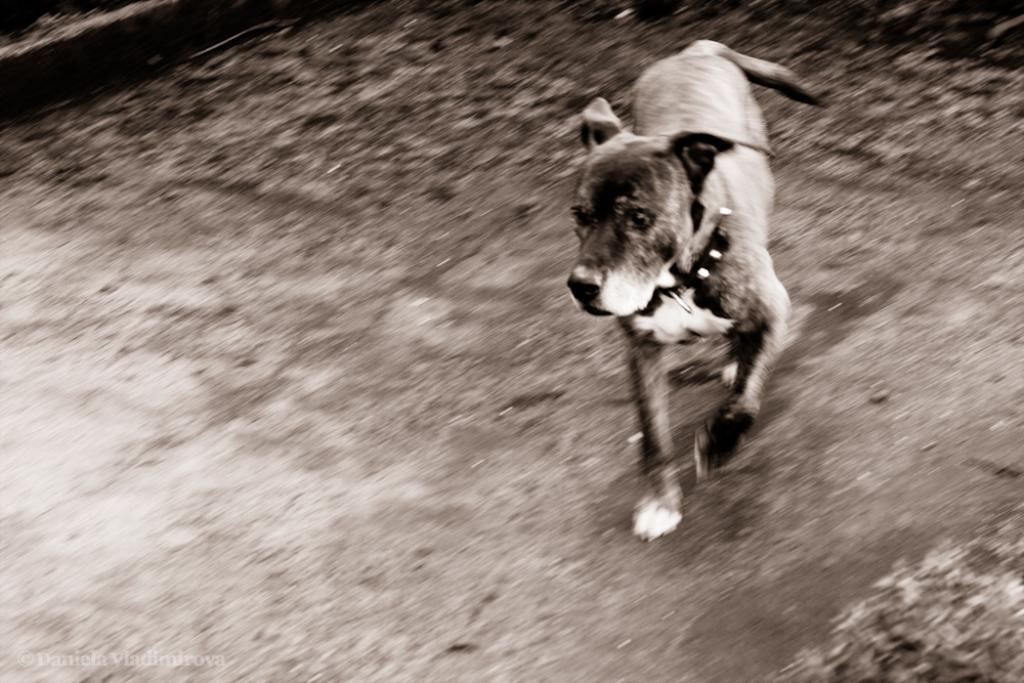What animal can be seen in the image? There is a dog in the image. What is the dog doing in the image? The dog is running on the ground. Can you describe the background of the image? The background of the image is blurry. What caption is written on the dog's collar in the image? There is no caption written on the dog's collar in the image, as the collar is not visible. 